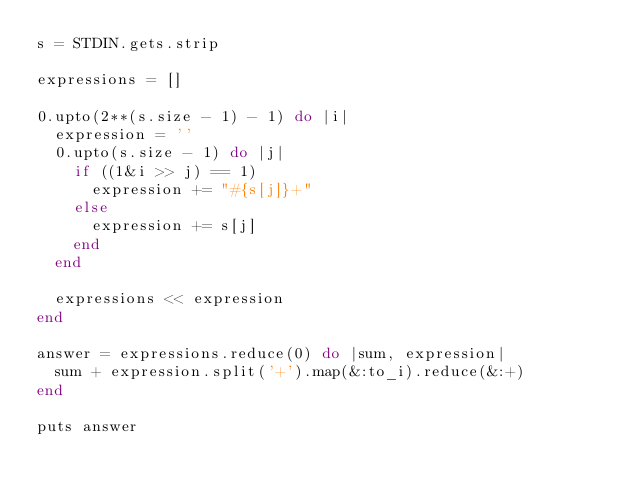Convert code to text. <code><loc_0><loc_0><loc_500><loc_500><_Ruby_>s = STDIN.gets.strip

expressions = []

0.upto(2**(s.size - 1) - 1) do |i|
  expression = ''
  0.upto(s.size - 1) do |j|
    if ((1&i >> j) == 1)
      expression += "#{s[j]}+"
    else
      expression += s[j]
    end
  end

  expressions << expression
end

answer = expressions.reduce(0) do |sum, expression|
  sum + expression.split('+').map(&:to_i).reduce(&:+)
end

puts answer</code> 